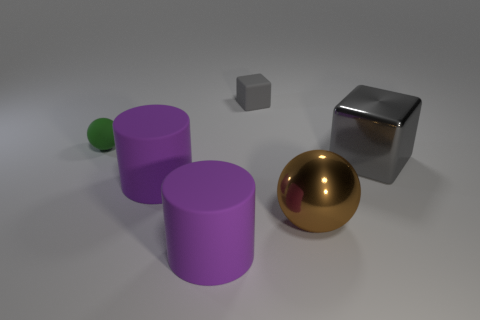What materials are the objects in the image likely made of? The objects in the image seem to be made of different materials. The matte gray cube could be made of stone or concrete, the shiny golden sphere might be metal, possibly brass or gold, the purple cylinders look like they could be made of rubber or plastic, and the small green sphere has the appearance of a rubber or plastic material as well. 